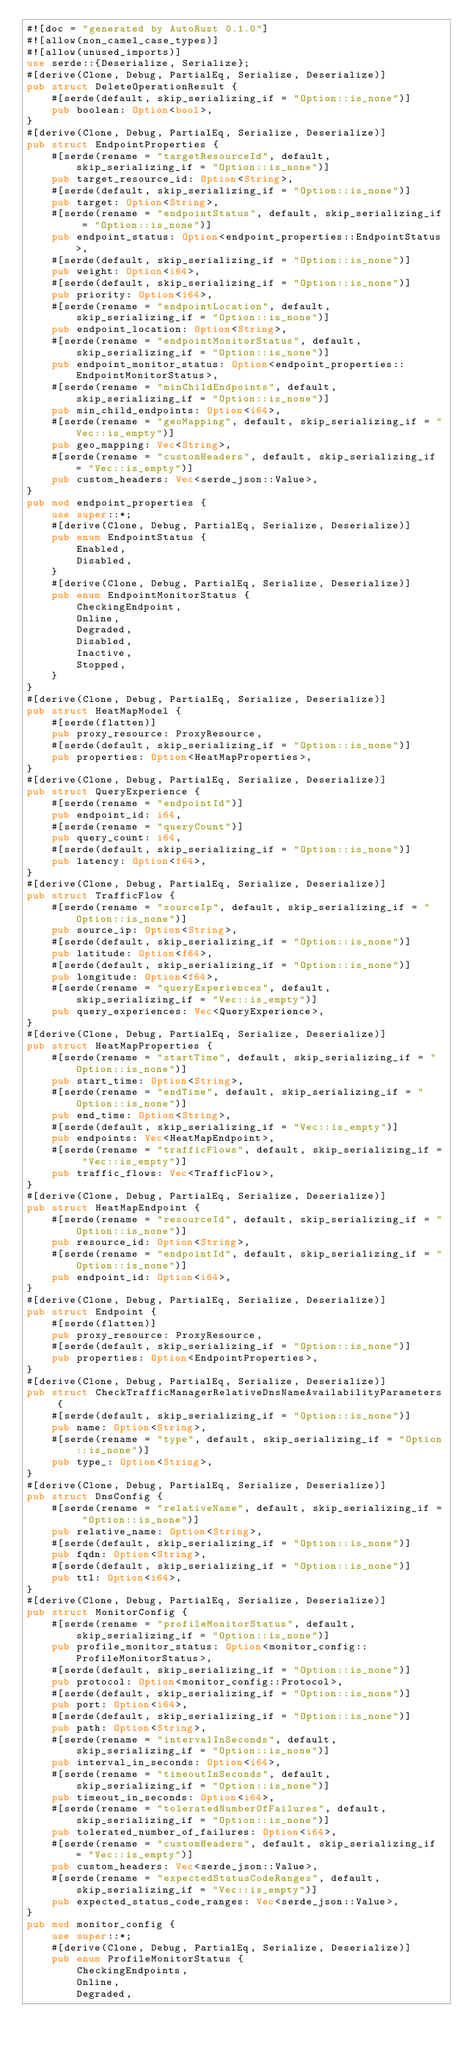Convert code to text. <code><loc_0><loc_0><loc_500><loc_500><_Rust_>#![doc = "generated by AutoRust 0.1.0"]
#![allow(non_camel_case_types)]
#![allow(unused_imports)]
use serde::{Deserialize, Serialize};
#[derive(Clone, Debug, PartialEq, Serialize, Deserialize)]
pub struct DeleteOperationResult {
    #[serde(default, skip_serializing_if = "Option::is_none")]
    pub boolean: Option<bool>,
}
#[derive(Clone, Debug, PartialEq, Serialize, Deserialize)]
pub struct EndpointProperties {
    #[serde(rename = "targetResourceId", default, skip_serializing_if = "Option::is_none")]
    pub target_resource_id: Option<String>,
    #[serde(default, skip_serializing_if = "Option::is_none")]
    pub target: Option<String>,
    #[serde(rename = "endpointStatus", default, skip_serializing_if = "Option::is_none")]
    pub endpoint_status: Option<endpoint_properties::EndpointStatus>,
    #[serde(default, skip_serializing_if = "Option::is_none")]
    pub weight: Option<i64>,
    #[serde(default, skip_serializing_if = "Option::is_none")]
    pub priority: Option<i64>,
    #[serde(rename = "endpointLocation", default, skip_serializing_if = "Option::is_none")]
    pub endpoint_location: Option<String>,
    #[serde(rename = "endpointMonitorStatus", default, skip_serializing_if = "Option::is_none")]
    pub endpoint_monitor_status: Option<endpoint_properties::EndpointMonitorStatus>,
    #[serde(rename = "minChildEndpoints", default, skip_serializing_if = "Option::is_none")]
    pub min_child_endpoints: Option<i64>,
    #[serde(rename = "geoMapping", default, skip_serializing_if = "Vec::is_empty")]
    pub geo_mapping: Vec<String>,
    #[serde(rename = "customHeaders", default, skip_serializing_if = "Vec::is_empty")]
    pub custom_headers: Vec<serde_json::Value>,
}
pub mod endpoint_properties {
    use super::*;
    #[derive(Clone, Debug, PartialEq, Serialize, Deserialize)]
    pub enum EndpointStatus {
        Enabled,
        Disabled,
    }
    #[derive(Clone, Debug, PartialEq, Serialize, Deserialize)]
    pub enum EndpointMonitorStatus {
        CheckingEndpoint,
        Online,
        Degraded,
        Disabled,
        Inactive,
        Stopped,
    }
}
#[derive(Clone, Debug, PartialEq, Serialize, Deserialize)]
pub struct HeatMapModel {
    #[serde(flatten)]
    pub proxy_resource: ProxyResource,
    #[serde(default, skip_serializing_if = "Option::is_none")]
    pub properties: Option<HeatMapProperties>,
}
#[derive(Clone, Debug, PartialEq, Serialize, Deserialize)]
pub struct QueryExperience {
    #[serde(rename = "endpointId")]
    pub endpoint_id: i64,
    #[serde(rename = "queryCount")]
    pub query_count: i64,
    #[serde(default, skip_serializing_if = "Option::is_none")]
    pub latency: Option<f64>,
}
#[derive(Clone, Debug, PartialEq, Serialize, Deserialize)]
pub struct TrafficFlow {
    #[serde(rename = "sourceIp", default, skip_serializing_if = "Option::is_none")]
    pub source_ip: Option<String>,
    #[serde(default, skip_serializing_if = "Option::is_none")]
    pub latitude: Option<f64>,
    #[serde(default, skip_serializing_if = "Option::is_none")]
    pub longitude: Option<f64>,
    #[serde(rename = "queryExperiences", default, skip_serializing_if = "Vec::is_empty")]
    pub query_experiences: Vec<QueryExperience>,
}
#[derive(Clone, Debug, PartialEq, Serialize, Deserialize)]
pub struct HeatMapProperties {
    #[serde(rename = "startTime", default, skip_serializing_if = "Option::is_none")]
    pub start_time: Option<String>,
    #[serde(rename = "endTime", default, skip_serializing_if = "Option::is_none")]
    pub end_time: Option<String>,
    #[serde(default, skip_serializing_if = "Vec::is_empty")]
    pub endpoints: Vec<HeatMapEndpoint>,
    #[serde(rename = "trafficFlows", default, skip_serializing_if = "Vec::is_empty")]
    pub traffic_flows: Vec<TrafficFlow>,
}
#[derive(Clone, Debug, PartialEq, Serialize, Deserialize)]
pub struct HeatMapEndpoint {
    #[serde(rename = "resourceId", default, skip_serializing_if = "Option::is_none")]
    pub resource_id: Option<String>,
    #[serde(rename = "endpointId", default, skip_serializing_if = "Option::is_none")]
    pub endpoint_id: Option<i64>,
}
#[derive(Clone, Debug, PartialEq, Serialize, Deserialize)]
pub struct Endpoint {
    #[serde(flatten)]
    pub proxy_resource: ProxyResource,
    #[serde(default, skip_serializing_if = "Option::is_none")]
    pub properties: Option<EndpointProperties>,
}
#[derive(Clone, Debug, PartialEq, Serialize, Deserialize)]
pub struct CheckTrafficManagerRelativeDnsNameAvailabilityParameters {
    #[serde(default, skip_serializing_if = "Option::is_none")]
    pub name: Option<String>,
    #[serde(rename = "type", default, skip_serializing_if = "Option::is_none")]
    pub type_: Option<String>,
}
#[derive(Clone, Debug, PartialEq, Serialize, Deserialize)]
pub struct DnsConfig {
    #[serde(rename = "relativeName", default, skip_serializing_if = "Option::is_none")]
    pub relative_name: Option<String>,
    #[serde(default, skip_serializing_if = "Option::is_none")]
    pub fqdn: Option<String>,
    #[serde(default, skip_serializing_if = "Option::is_none")]
    pub ttl: Option<i64>,
}
#[derive(Clone, Debug, PartialEq, Serialize, Deserialize)]
pub struct MonitorConfig {
    #[serde(rename = "profileMonitorStatus", default, skip_serializing_if = "Option::is_none")]
    pub profile_monitor_status: Option<monitor_config::ProfileMonitorStatus>,
    #[serde(default, skip_serializing_if = "Option::is_none")]
    pub protocol: Option<monitor_config::Protocol>,
    #[serde(default, skip_serializing_if = "Option::is_none")]
    pub port: Option<i64>,
    #[serde(default, skip_serializing_if = "Option::is_none")]
    pub path: Option<String>,
    #[serde(rename = "intervalInSeconds", default, skip_serializing_if = "Option::is_none")]
    pub interval_in_seconds: Option<i64>,
    #[serde(rename = "timeoutInSeconds", default, skip_serializing_if = "Option::is_none")]
    pub timeout_in_seconds: Option<i64>,
    #[serde(rename = "toleratedNumberOfFailures", default, skip_serializing_if = "Option::is_none")]
    pub tolerated_number_of_failures: Option<i64>,
    #[serde(rename = "customHeaders", default, skip_serializing_if = "Vec::is_empty")]
    pub custom_headers: Vec<serde_json::Value>,
    #[serde(rename = "expectedStatusCodeRanges", default, skip_serializing_if = "Vec::is_empty")]
    pub expected_status_code_ranges: Vec<serde_json::Value>,
}
pub mod monitor_config {
    use super::*;
    #[derive(Clone, Debug, PartialEq, Serialize, Deserialize)]
    pub enum ProfileMonitorStatus {
        CheckingEndpoints,
        Online,
        Degraded,</code> 